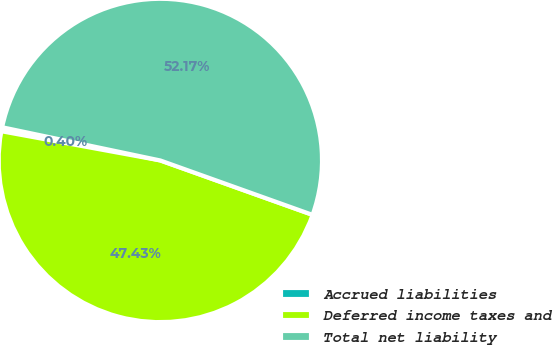Convert chart. <chart><loc_0><loc_0><loc_500><loc_500><pie_chart><fcel>Accrued liabilities<fcel>Deferred income taxes and<fcel>Total net liability<nl><fcel>0.4%<fcel>47.43%<fcel>52.17%<nl></chart> 